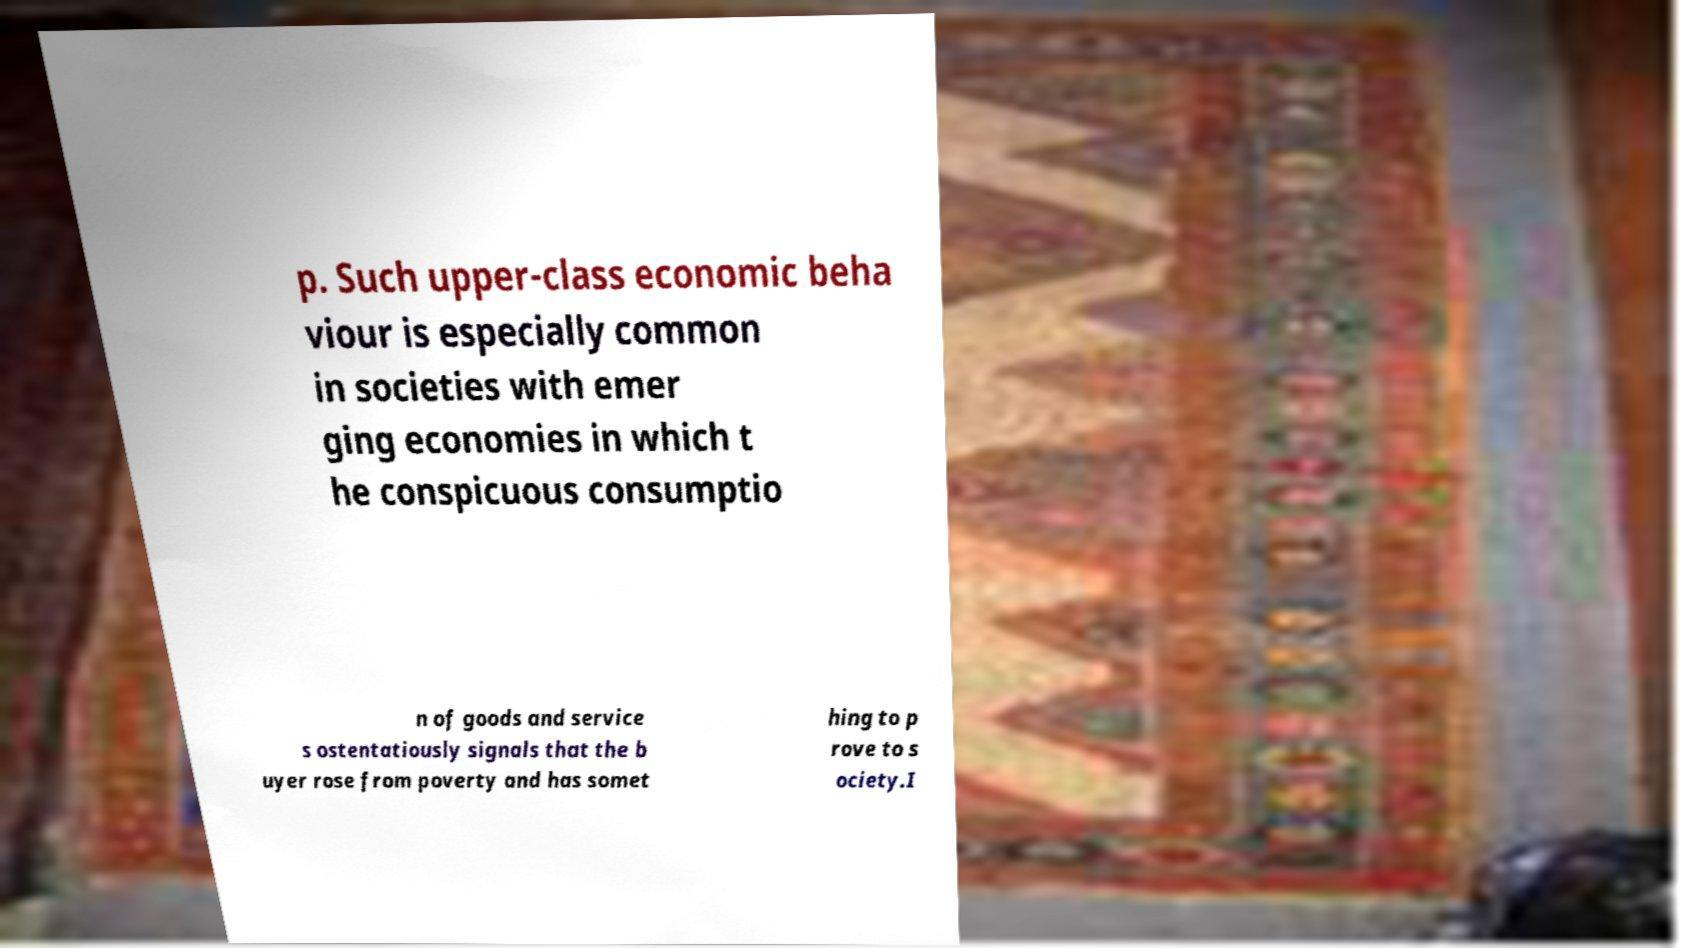Can you read and provide the text displayed in the image?This photo seems to have some interesting text. Can you extract and type it out for me? p. Such upper-class economic beha viour is especially common in societies with emer ging economies in which t he conspicuous consumptio n of goods and service s ostentatiously signals that the b uyer rose from poverty and has somet hing to p rove to s ociety.I 